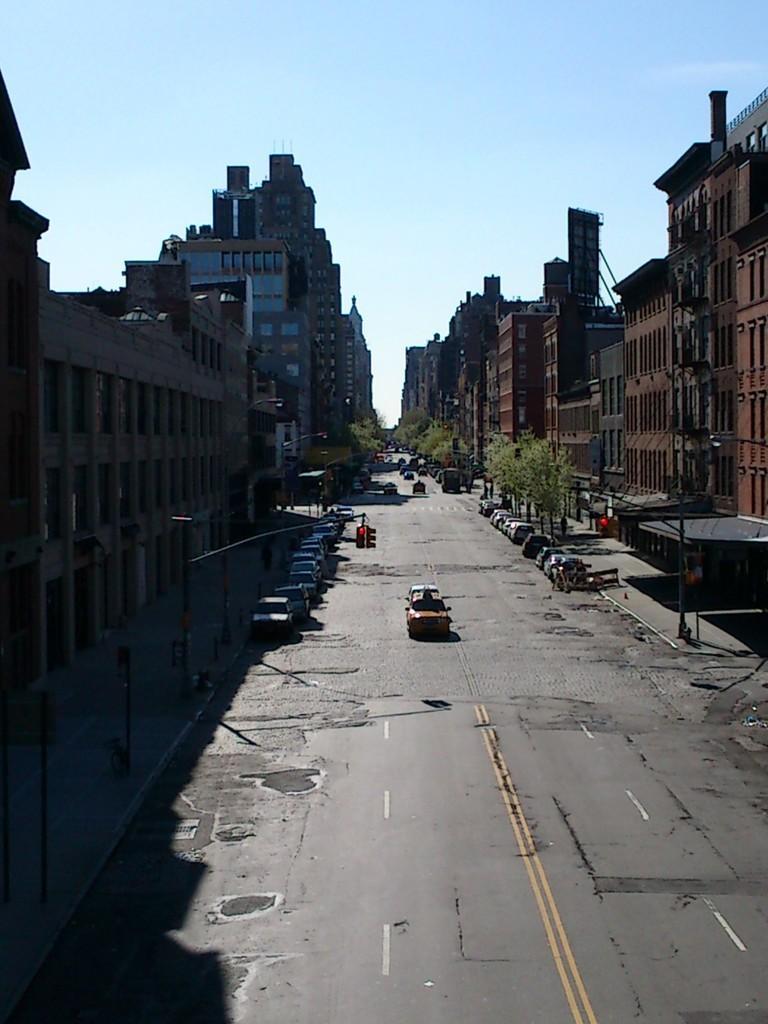Describe this image in one or two sentences. In the image there is a road in the front with cars on either side of it, behind it there are buildings with trees in front of it and above its sky. 